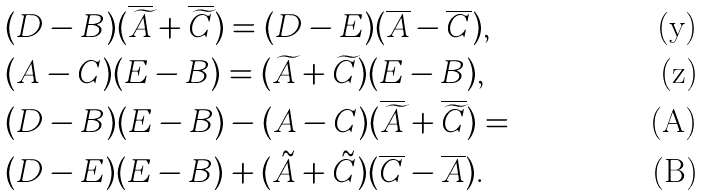Convert formula to latex. <formula><loc_0><loc_0><loc_500><loc_500>& ( D - B ) ( \overline { \widetilde { A } } + \overline { \widetilde { C } } ) = ( D - E ) ( \overline { A } - \overline { C } ) , \\ & ( A - C ) ( E - B ) = ( \widetilde { A } + \widetilde { C } ) ( E - B ) , \\ & ( D - B ) ( E - B ) - ( A - C ) ( \overline { \widetilde { A } } + \overline { \widetilde { C } } ) = \\ & ( D - E ) ( E - B ) + ( \tilde { A } + \tilde { C } ) ( \overline { C } - \overline { A } ) .</formula> 